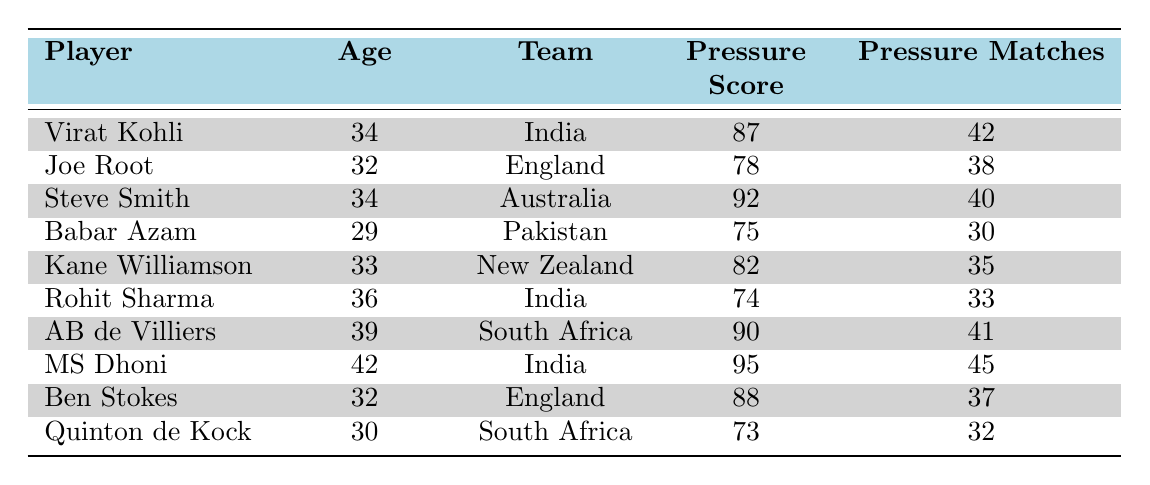What is the pressure performance score of MS Dhoni? The table lists MS Dhoni's pressure performance score in the corresponding column. His score is 95.
Answer: 95 Which player has the highest pressure performance score? By comparing the pressure performance scores in the table, MS Dhoni has the highest score at 95.
Answer: MS Dhoni What is the average age of the players listed in the table? The ages are: 34, 32, 34, 29, 33, 36, 39, 42, 32, and 30. There are 10 players, with a total age sum of 34 + 32 + 34 + 29 + 33 + 36 + 39 + 42 + 32 + 30 =  340. The average is 340 / 10 = 34.
Answer: 34 True or False: The average pressure performance score for players aged 30 and above is greater than 80. Players aged 30 and above are: Virat Kohli (87), Joe Root (78), Steve Smith (92), Kane Williamson (82), Rohit Sharma (74), AB de Villiers (90), MS Dhoni (95), and Ben Stokes (88). Their average is (87 + 78 + 92 + 82 + 74 + 90 + 95 + 88) / 8 = 86.25, which is greater than 80.
Answer: True How many matches under pressure did players aged 34 and older participate in? The relevant players are Steve Smith (34, 40), Rohit Sharma (36, 33), AB de Villiers (39, 41), and MS Dhoni (42, 45), totaling 40 + 33 + 41 + 45 = 159 matches.
Answer: 159 What is the difference in pressure performance scores between the youngest (Babar Azam) and the oldest (MS Dhoni) player? Babar Azam's score is 75 and MS Dhoni's score is 95, calculated as 95 - 75 = 20.
Answer: 20 Which team has the youngest player according to this table? Babar Azam is 29 and the youngest player, representing Pakistan.
Answer: Pakistan How many players scored less than 80 in their pressure performance score? Players with scores less than 80 are Joe Root (78), Babar Azam (75), and Quinton de Kock (73), totaling 3 players.
Answer: 3 Which player has matched the highest number of games under pressure? MS Dhoni has participated in 45 matches under pressure, which is the highest.
Answer: MS Dhoni If we categorize the players into two groups based on their age (below 30 and 30 and above), how many players are there in each group? Below 30: Babar Azam (1). 30 and above: Virat Kohli, Joe Root, Steve Smith, Kane Williamson, Rohit Sharma, AB de Villiers, MS Dhoni, Ben Stokes, and Quinton de Kock (totaling 9 players).
Answer: 1 below 30, 9 above 30 